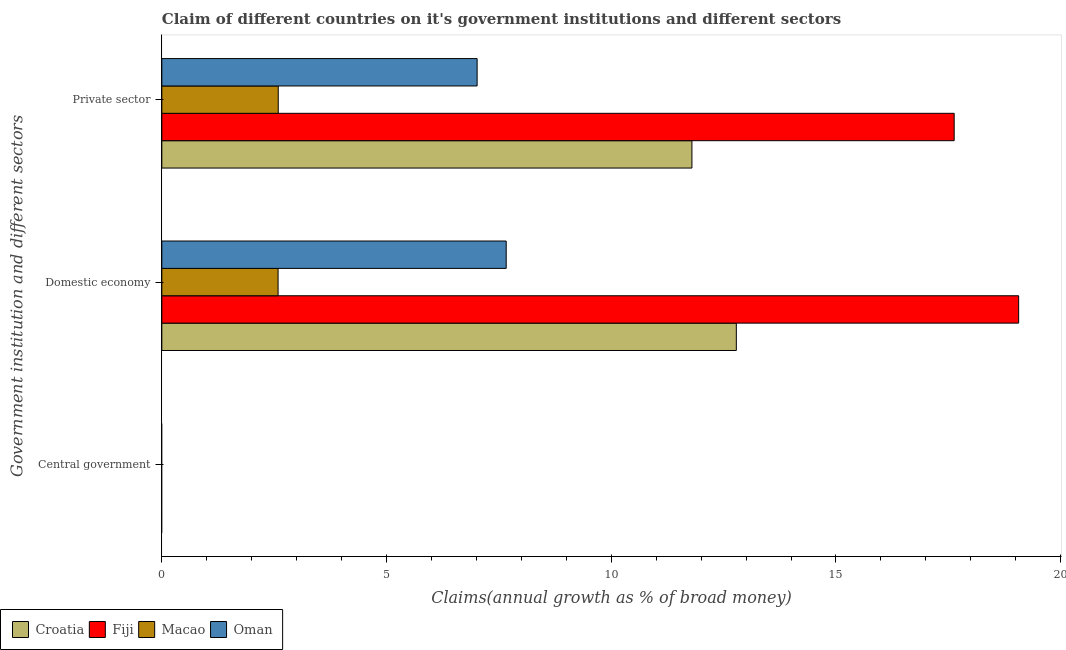Are the number of bars per tick equal to the number of legend labels?
Keep it short and to the point. No. Are the number of bars on each tick of the Y-axis equal?
Your response must be concise. No. How many bars are there on the 2nd tick from the top?
Keep it short and to the point. 4. What is the label of the 2nd group of bars from the top?
Ensure brevity in your answer.  Domestic economy. What is the percentage of claim on the private sector in Fiji?
Provide a short and direct response. 17.63. Across all countries, what is the maximum percentage of claim on the private sector?
Your response must be concise. 17.63. Across all countries, what is the minimum percentage of claim on the domestic economy?
Provide a succinct answer. 2.59. In which country was the percentage of claim on the domestic economy maximum?
Make the answer very short. Fiji. What is the difference between the percentage of claim on the domestic economy in Fiji and that in Macao?
Your answer should be compact. 16.48. What is the difference between the percentage of claim on the private sector in Fiji and the percentage of claim on the domestic economy in Croatia?
Offer a terse response. 4.85. What is the average percentage of claim on the central government per country?
Your answer should be compact. 0. What is the difference between the percentage of claim on the private sector and percentage of claim on the domestic economy in Croatia?
Offer a terse response. -0.99. In how many countries, is the percentage of claim on the private sector greater than 14 %?
Your response must be concise. 1. What is the ratio of the percentage of claim on the domestic economy in Oman to that in Croatia?
Ensure brevity in your answer.  0.6. What is the difference between the highest and the second highest percentage of claim on the domestic economy?
Give a very brief answer. 6.28. What is the difference between the highest and the lowest percentage of claim on the private sector?
Give a very brief answer. 15.04. Is it the case that in every country, the sum of the percentage of claim on the central government and percentage of claim on the domestic economy is greater than the percentage of claim on the private sector?
Give a very brief answer. No. What is the difference between two consecutive major ticks on the X-axis?
Make the answer very short. 5. Are the values on the major ticks of X-axis written in scientific E-notation?
Offer a terse response. No. Does the graph contain any zero values?
Offer a terse response. Yes. Where does the legend appear in the graph?
Your answer should be very brief. Bottom left. How many legend labels are there?
Provide a succinct answer. 4. How are the legend labels stacked?
Your answer should be compact. Horizontal. What is the title of the graph?
Offer a terse response. Claim of different countries on it's government institutions and different sectors. Does "New Caledonia" appear as one of the legend labels in the graph?
Ensure brevity in your answer.  No. What is the label or title of the X-axis?
Your response must be concise. Claims(annual growth as % of broad money). What is the label or title of the Y-axis?
Offer a very short reply. Government institution and different sectors. What is the Claims(annual growth as % of broad money) in Fiji in Central government?
Ensure brevity in your answer.  0. What is the Claims(annual growth as % of broad money) in Oman in Central government?
Your answer should be very brief. 0. What is the Claims(annual growth as % of broad money) in Croatia in Domestic economy?
Ensure brevity in your answer.  12.78. What is the Claims(annual growth as % of broad money) in Fiji in Domestic economy?
Provide a succinct answer. 19.07. What is the Claims(annual growth as % of broad money) in Macao in Domestic economy?
Provide a short and direct response. 2.59. What is the Claims(annual growth as % of broad money) in Oman in Domestic economy?
Make the answer very short. 7.66. What is the Claims(annual growth as % of broad money) in Croatia in Private sector?
Your answer should be very brief. 11.8. What is the Claims(annual growth as % of broad money) in Fiji in Private sector?
Keep it short and to the point. 17.63. What is the Claims(annual growth as % of broad money) of Macao in Private sector?
Your answer should be compact. 2.59. What is the Claims(annual growth as % of broad money) in Oman in Private sector?
Offer a very short reply. 7.02. Across all Government institution and different sectors, what is the maximum Claims(annual growth as % of broad money) in Croatia?
Your response must be concise. 12.78. Across all Government institution and different sectors, what is the maximum Claims(annual growth as % of broad money) of Fiji?
Offer a very short reply. 19.07. Across all Government institution and different sectors, what is the maximum Claims(annual growth as % of broad money) in Macao?
Provide a short and direct response. 2.59. Across all Government institution and different sectors, what is the maximum Claims(annual growth as % of broad money) in Oman?
Make the answer very short. 7.66. Across all Government institution and different sectors, what is the minimum Claims(annual growth as % of broad money) of Macao?
Keep it short and to the point. 0. Across all Government institution and different sectors, what is the minimum Claims(annual growth as % of broad money) of Oman?
Make the answer very short. 0. What is the total Claims(annual growth as % of broad money) in Croatia in the graph?
Keep it short and to the point. 24.58. What is the total Claims(annual growth as % of broad money) in Fiji in the graph?
Your answer should be compact. 36.7. What is the total Claims(annual growth as % of broad money) in Macao in the graph?
Provide a short and direct response. 5.18. What is the total Claims(annual growth as % of broad money) in Oman in the graph?
Ensure brevity in your answer.  14.68. What is the difference between the Claims(annual growth as % of broad money) of Croatia in Domestic economy and that in Private sector?
Your response must be concise. 0.99. What is the difference between the Claims(annual growth as % of broad money) in Fiji in Domestic economy and that in Private sector?
Provide a succinct answer. 1.43. What is the difference between the Claims(annual growth as % of broad money) of Macao in Domestic economy and that in Private sector?
Your response must be concise. -0. What is the difference between the Claims(annual growth as % of broad money) in Oman in Domestic economy and that in Private sector?
Give a very brief answer. 0.65. What is the difference between the Claims(annual growth as % of broad money) in Croatia in Domestic economy and the Claims(annual growth as % of broad money) in Fiji in Private sector?
Provide a succinct answer. -4.85. What is the difference between the Claims(annual growth as % of broad money) of Croatia in Domestic economy and the Claims(annual growth as % of broad money) of Macao in Private sector?
Provide a succinct answer. 10.19. What is the difference between the Claims(annual growth as % of broad money) in Croatia in Domestic economy and the Claims(annual growth as % of broad money) in Oman in Private sector?
Your answer should be very brief. 5.77. What is the difference between the Claims(annual growth as % of broad money) of Fiji in Domestic economy and the Claims(annual growth as % of broad money) of Macao in Private sector?
Your answer should be very brief. 16.47. What is the difference between the Claims(annual growth as % of broad money) of Fiji in Domestic economy and the Claims(annual growth as % of broad money) of Oman in Private sector?
Provide a short and direct response. 12.05. What is the difference between the Claims(annual growth as % of broad money) of Macao in Domestic economy and the Claims(annual growth as % of broad money) of Oman in Private sector?
Your answer should be very brief. -4.43. What is the average Claims(annual growth as % of broad money) in Croatia per Government institution and different sectors?
Keep it short and to the point. 8.19. What is the average Claims(annual growth as % of broad money) in Fiji per Government institution and different sectors?
Ensure brevity in your answer.  12.23. What is the average Claims(annual growth as % of broad money) of Macao per Government institution and different sectors?
Make the answer very short. 1.73. What is the average Claims(annual growth as % of broad money) of Oman per Government institution and different sectors?
Your answer should be very brief. 4.89. What is the difference between the Claims(annual growth as % of broad money) of Croatia and Claims(annual growth as % of broad money) of Fiji in Domestic economy?
Provide a short and direct response. -6.28. What is the difference between the Claims(annual growth as % of broad money) of Croatia and Claims(annual growth as % of broad money) of Macao in Domestic economy?
Offer a very short reply. 10.2. What is the difference between the Claims(annual growth as % of broad money) in Croatia and Claims(annual growth as % of broad money) in Oman in Domestic economy?
Offer a very short reply. 5.12. What is the difference between the Claims(annual growth as % of broad money) of Fiji and Claims(annual growth as % of broad money) of Macao in Domestic economy?
Keep it short and to the point. 16.48. What is the difference between the Claims(annual growth as % of broad money) in Fiji and Claims(annual growth as % of broad money) in Oman in Domestic economy?
Provide a succinct answer. 11.4. What is the difference between the Claims(annual growth as % of broad money) in Macao and Claims(annual growth as % of broad money) in Oman in Domestic economy?
Provide a short and direct response. -5.08. What is the difference between the Claims(annual growth as % of broad money) of Croatia and Claims(annual growth as % of broad money) of Fiji in Private sector?
Your answer should be compact. -5.84. What is the difference between the Claims(annual growth as % of broad money) in Croatia and Claims(annual growth as % of broad money) in Macao in Private sector?
Provide a short and direct response. 9.2. What is the difference between the Claims(annual growth as % of broad money) in Croatia and Claims(annual growth as % of broad money) in Oman in Private sector?
Ensure brevity in your answer.  4.78. What is the difference between the Claims(annual growth as % of broad money) of Fiji and Claims(annual growth as % of broad money) of Macao in Private sector?
Provide a short and direct response. 15.04. What is the difference between the Claims(annual growth as % of broad money) in Fiji and Claims(annual growth as % of broad money) in Oman in Private sector?
Make the answer very short. 10.61. What is the difference between the Claims(annual growth as % of broad money) in Macao and Claims(annual growth as % of broad money) in Oman in Private sector?
Ensure brevity in your answer.  -4.43. What is the ratio of the Claims(annual growth as % of broad money) in Croatia in Domestic economy to that in Private sector?
Make the answer very short. 1.08. What is the ratio of the Claims(annual growth as % of broad money) in Fiji in Domestic economy to that in Private sector?
Provide a short and direct response. 1.08. What is the ratio of the Claims(annual growth as % of broad money) of Oman in Domestic economy to that in Private sector?
Ensure brevity in your answer.  1.09. What is the difference between the highest and the lowest Claims(annual growth as % of broad money) in Croatia?
Provide a succinct answer. 12.78. What is the difference between the highest and the lowest Claims(annual growth as % of broad money) in Fiji?
Give a very brief answer. 19.07. What is the difference between the highest and the lowest Claims(annual growth as % of broad money) of Macao?
Give a very brief answer. 2.59. What is the difference between the highest and the lowest Claims(annual growth as % of broad money) of Oman?
Offer a terse response. 7.66. 